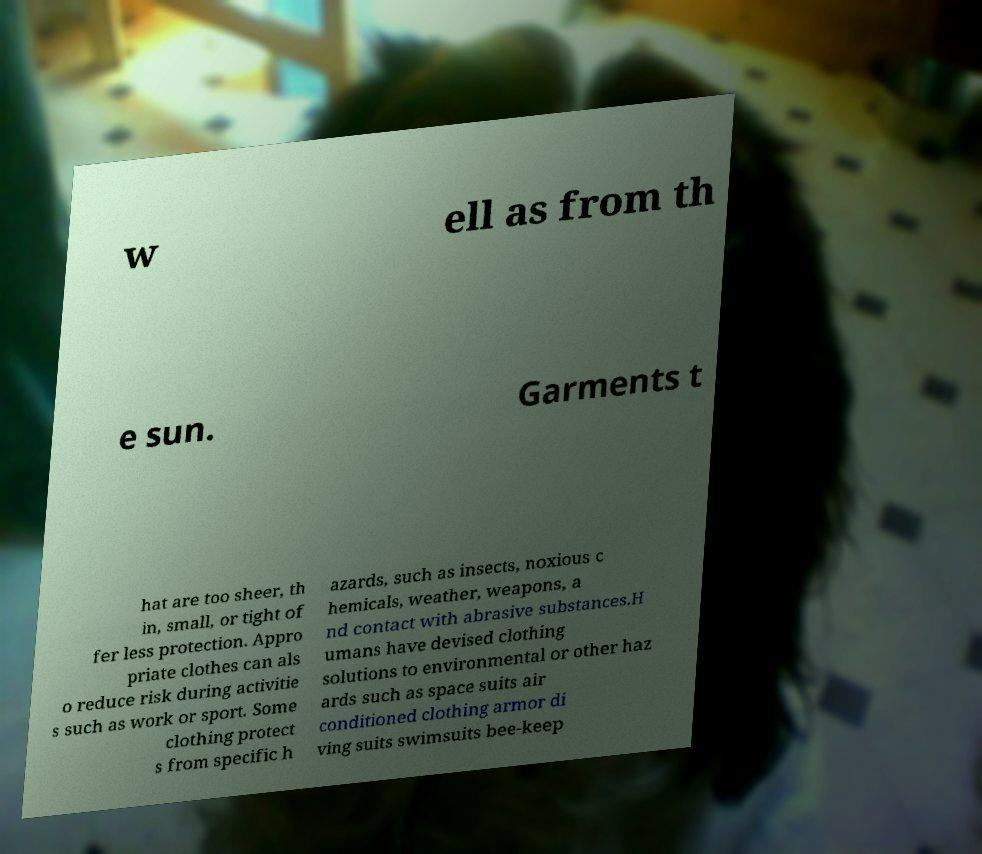Can you read and provide the text displayed in the image?This photo seems to have some interesting text. Can you extract and type it out for me? w ell as from th e sun. Garments t hat are too sheer, th in, small, or tight of fer less protection. Appro priate clothes can als o reduce risk during activitie s such as work or sport. Some clothing protect s from specific h azards, such as insects, noxious c hemicals, weather, weapons, a nd contact with abrasive substances.H umans have devised clothing solutions to environmental or other haz ards such as space suits air conditioned clothing armor di ving suits swimsuits bee-keep 